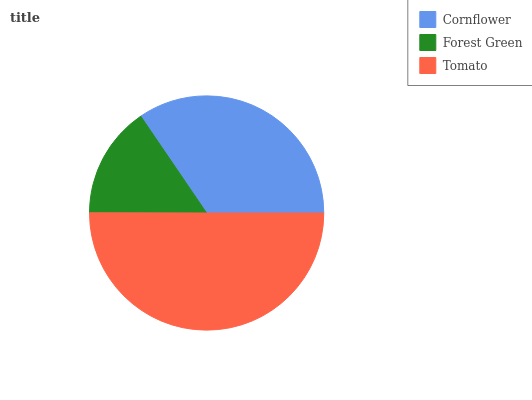Is Forest Green the minimum?
Answer yes or no. Yes. Is Tomato the maximum?
Answer yes or no. Yes. Is Tomato the minimum?
Answer yes or no. No. Is Forest Green the maximum?
Answer yes or no. No. Is Tomato greater than Forest Green?
Answer yes or no. Yes. Is Forest Green less than Tomato?
Answer yes or no. Yes. Is Forest Green greater than Tomato?
Answer yes or no. No. Is Tomato less than Forest Green?
Answer yes or no. No. Is Cornflower the high median?
Answer yes or no. Yes. Is Cornflower the low median?
Answer yes or no. Yes. Is Forest Green the high median?
Answer yes or no. No. Is Tomato the low median?
Answer yes or no. No. 